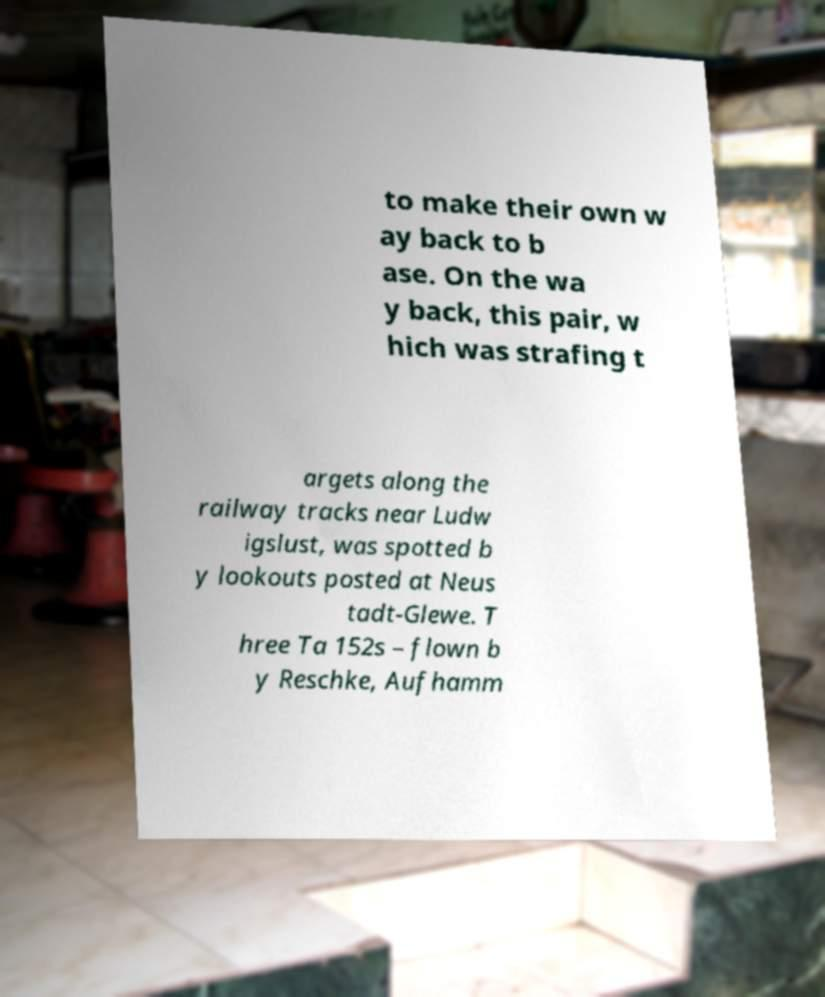I need the written content from this picture converted into text. Can you do that? to make their own w ay back to b ase. On the wa y back, this pair, w hich was strafing t argets along the railway tracks near Ludw igslust, was spotted b y lookouts posted at Neus tadt-Glewe. T hree Ta 152s – flown b y Reschke, Aufhamm 